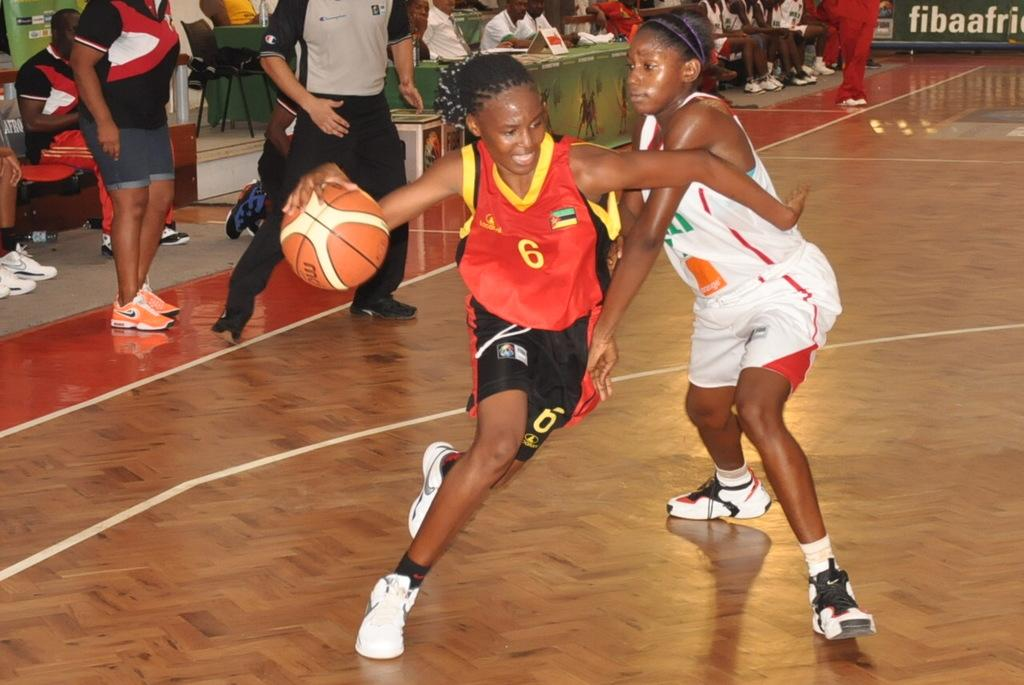Provide a one-sentence caption for the provided image. Two females play basketball basketball in the court with an advertisement that says "fibaafric". 